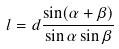<formula> <loc_0><loc_0><loc_500><loc_500>l = d \frac { \sin ( \alpha + \beta ) } { \sin \alpha \sin \beta }</formula> 